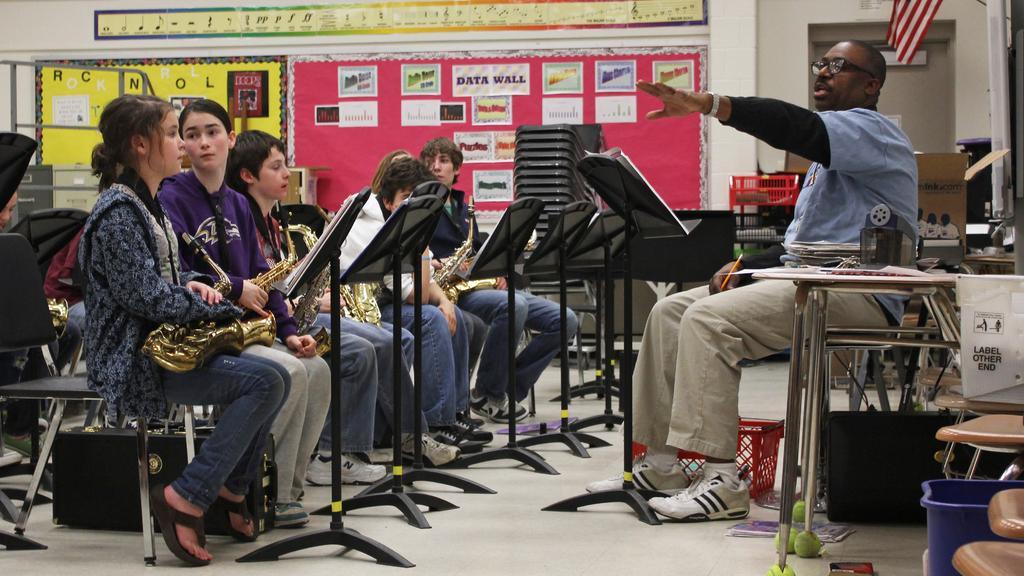In one or two sentences, can you explain what this image depicts? In this image we can see the people sitting on the chairs. We can also see the papers attached to the black color stands. On the right we can see the blue color bin, table, poster, cardboard box and also the flag in the background. We can also see the poster and also the door. At the bottom we can see the floor and also the red color basket. 